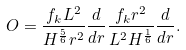Convert formula to latex. <formula><loc_0><loc_0><loc_500><loc_500>O = \frac { f _ { k } L ^ { 2 } } { H ^ { \frac { 5 } { 6 } } r ^ { 2 } } \frac { d } { d r } \frac { f _ { k } r ^ { 2 } } { L ^ { 2 } H ^ { \frac { 1 } { 6 } } } \frac { d } { d r } .</formula> 